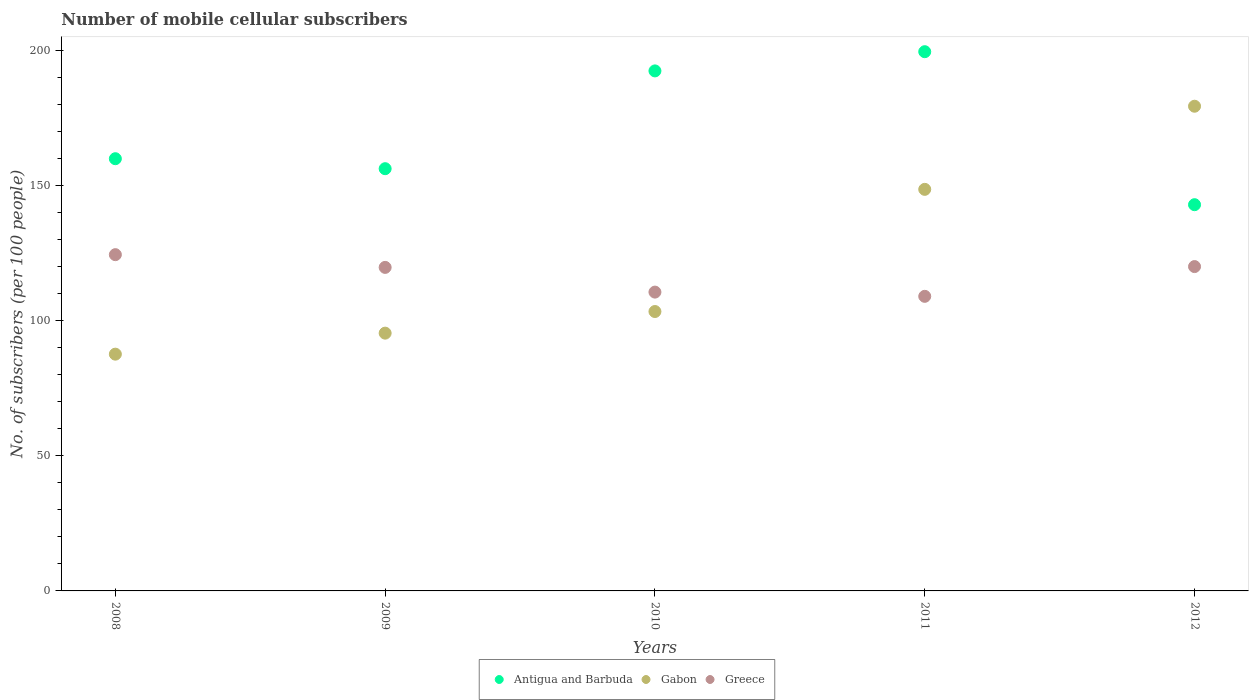What is the number of mobile cellular subscribers in Greece in 2011?
Your response must be concise. 109.08. Across all years, what is the maximum number of mobile cellular subscribers in Antigua and Barbuda?
Ensure brevity in your answer.  199.66. Across all years, what is the minimum number of mobile cellular subscribers in Antigua and Barbuda?
Keep it short and to the point. 143.01. In which year was the number of mobile cellular subscribers in Antigua and Barbuda maximum?
Your response must be concise. 2011. What is the total number of mobile cellular subscribers in Antigua and Barbuda in the graph?
Keep it short and to the point. 851.61. What is the difference between the number of mobile cellular subscribers in Gabon in 2009 and that in 2010?
Provide a succinct answer. -8.01. What is the difference between the number of mobile cellular subscribers in Greece in 2011 and the number of mobile cellular subscribers in Antigua and Barbuda in 2008?
Give a very brief answer. -50.96. What is the average number of mobile cellular subscribers in Greece per year?
Your answer should be compact. 116.82. In the year 2011, what is the difference between the number of mobile cellular subscribers in Gabon and number of mobile cellular subscribers in Antigua and Barbuda?
Offer a very short reply. -50.97. What is the ratio of the number of mobile cellular subscribers in Antigua and Barbuda in 2008 to that in 2009?
Keep it short and to the point. 1.02. Is the number of mobile cellular subscribers in Greece in 2010 less than that in 2012?
Provide a succinct answer. Yes. Is the difference between the number of mobile cellular subscribers in Gabon in 2008 and 2009 greater than the difference between the number of mobile cellular subscribers in Antigua and Barbuda in 2008 and 2009?
Offer a terse response. No. What is the difference between the highest and the second highest number of mobile cellular subscribers in Gabon?
Your answer should be compact. 30.78. What is the difference between the highest and the lowest number of mobile cellular subscribers in Gabon?
Provide a succinct answer. 91.8. Is the sum of the number of mobile cellular subscribers in Greece in 2008 and 2012 greater than the maximum number of mobile cellular subscribers in Antigua and Barbuda across all years?
Your answer should be compact. Yes. Is it the case that in every year, the sum of the number of mobile cellular subscribers in Greece and number of mobile cellular subscribers in Gabon  is greater than the number of mobile cellular subscribers in Antigua and Barbuda?
Your answer should be very brief. Yes. How many years are there in the graph?
Provide a short and direct response. 5. What is the difference between two consecutive major ticks on the Y-axis?
Your response must be concise. 50. How are the legend labels stacked?
Provide a succinct answer. Horizontal. What is the title of the graph?
Offer a terse response. Number of mobile cellular subscribers. Does "Madagascar" appear as one of the legend labels in the graph?
Ensure brevity in your answer.  No. What is the label or title of the Y-axis?
Keep it short and to the point. No. of subscribers (per 100 people). What is the No. of subscribers (per 100 people) of Antigua and Barbuda in 2008?
Offer a very short reply. 160.04. What is the No. of subscribers (per 100 people) in Gabon in 2008?
Keep it short and to the point. 87.67. What is the No. of subscribers (per 100 people) of Greece in 2008?
Offer a terse response. 124.51. What is the No. of subscribers (per 100 people) in Antigua and Barbuda in 2009?
Your response must be concise. 156.34. What is the No. of subscribers (per 100 people) of Gabon in 2009?
Provide a short and direct response. 95.45. What is the No. of subscribers (per 100 people) in Greece in 2009?
Make the answer very short. 119.8. What is the No. of subscribers (per 100 people) of Antigua and Barbuda in 2010?
Offer a very short reply. 192.55. What is the No. of subscribers (per 100 people) of Gabon in 2010?
Keep it short and to the point. 103.46. What is the No. of subscribers (per 100 people) of Greece in 2010?
Provide a short and direct response. 110.65. What is the No. of subscribers (per 100 people) of Antigua and Barbuda in 2011?
Provide a succinct answer. 199.66. What is the No. of subscribers (per 100 people) of Gabon in 2011?
Make the answer very short. 148.69. What is the No. of subscribers (per 100 people) of Greece in 2011?
Offer a terse response. 109.08. What is the No. of subscribers (per 100 people) of Antigua and Barbuda in 2012?
Your response must be concise. 143.01. What is the No. of subscribers (per 100 people) of Gabon in 2012?
Provide a succinct answer. 179.47. What is the No. of subscribers (per 100 people) in Greece in 2012?
Make the answer very short. 120.1. Across all years, what is the maximum No. of subscribers (per 100 people) in Antigua and Barbuda?
Offer a terse response. 199.66. Across all years, what is the maximum No. of subscribers (per 100 people) in Gabon?
Ensure brevity in your answer.  179.47. Across all years, what is the maximum No. of subscribers (per 100 people) in Greece?
Provide a short and direct response. 124.51. Across all years, what is the minimum No. of subscribers (per 100 people) in Antigua and Barbuda?
Keep it short and to the point. 143.01. Across all years, what is the minimum No. of subscribers (per 100 people) in Gabon?
Ensure brevity in your answer.  87.67. Across all years, what is the minimum No. of subscribers (per 100 people) in Greece?
Your answer should be compact. 109.08. What is the total No. of subscribers (per 100 people) in Antigua and Barbuda in the graph?
Provide a short and direct response. 851.61. What is the total No. of subscribers (per 100 people) in Gabon in the graph?
Provide a succinct answer. 614.74. What is the total No. of subscribers (per 100 people) of Greece in the graph?
Your answer should be very brief. 584.12. What is the difference between the No. of subscribers (per 100 people) in Antigua and Barbuda in 2008 and that in 2009?
Your answer should be very brief. 3.7. What is the difference between the No. of subscribers (per 100 people) of Gabon in 2008 and that in 2009?
Ensure brevity in your answer.  -7.78. What is the difference between the No. of subscribers (per 100 people) in Greece in 2008 and that in 2009?
Offer a terse response. 4.71. What is the difference between the No. of subscribers (per 100 people) in Antigua and Barbuda in 2008 and that in 2010?
Your answer should be compact. -32.51. What is the difference between the No. of subscribers (per 100 people) of Gabon in 2008 and that in 2010?
Your answer should be very brief. -15.79. What is the difference between the No. of subscribers (per 100 people) in Greece in 2008 and that in 2010?
Ensure brevity in your answer.  13.86. What is the difference between the No. of subscribers (per 100 people) of Antigua and Barbuda in 2008 and that in 2011?
Ensure brevity in your answer.  -39.62. What is the difference between the No. of subscribers (per 100 people) in Gabon in 2008 and that in 2011?
Your answer should be very brief. -61.02. What is the difference between the No. of subscribers (per 100 people) of Greece in 2008 and that in 2011?
Provide a short and direct response. 15.43. What is the difference between the No. of subscribers (per 100 people) in Antigua and Barbuda in 2008 and that in 2012?
Your response must be concise. 17.03. What is the difference between the No. of subscribers (per 100 people) of Gabon in 2008 and that in 2012?
Keep it short and to the point. -91.8. What is the difference between the No. of subscribers (per 100 people) of Greece in 2008 and that in 2012?
Give a very brief answer. 4.41. What is the difference between the No. of subscribers (per 100 people) of Antigua and Barbuda in 2009 and that in 2010?
Keep it short and to the point. -36.21. What is the difference between the No. of subscribers (per 100 people) in Gabon in 2009 and that in 2010?
Make the answer very short. -8.01. What is the difference between the No. of subscribers (per 100 people) of Greece in 2009 and that in 2010?
Make the answer very short. 9.15. What is the difference between the No. of subscribers (per 100 people) in Antigua and Barbuda in 2009 and that in 2011?
Your response must be concise. -43.32. What is the difference between the No. of subscribers (per 100 people) in Gabon in 2009 and that in 2011?
Your answer should be very brief. -53.25. What is the difference between the No. of subscribers (per 100 people) in Greece in 2009 and that in 2011?
Provide a succinct answer. 10.72. What is the difference between the No. of subscribers (per 100 people) in Antigua and Barbuda in 2009 and that in 2012?
Provide a succinct answer. 13.33. What is the difference between the No. of subscribers (per 100 people) of Gabon in 2009 and that in 2012?
Offer a very short reply. -84.02. What is the difference between the No. of subscribers (per 100 people) of Greece in 2009 and that in 2012?
Keep it short and to the point. -0.3. What is the difference between the No. of subscribers (per 100 people) in Antigua and Barbuda in 2010 and that in 2011?
Provide a succinct answer. -7.11. What is the difference between the No. of subscribers (per 100 people) in Gabon in 2010 and that in 2011?
Make the answer very short. -45.24. What is the difference between the No. of subscribers (per 100 people) in Greece in 2010 and that in 2011?
Provide a succinct answer. 1.57. What is the difference between the No. of subscribers (per 100 people) of Antigua and Barbuda in 2010 and that in 2012?
Provide a short and direct response. 49.54. What is the difference between the No. of subscribers (per 100 people) of Gabon in 2010 and that in 2012?
Provide a short and direct response. -76.02. What is the difference between the No. of subscribers (per 100 people) of Greece in 2010 and that in 2012?
Your answer should be very brief. -9.45. What is the difference between the No. of subscribers (per 100 people) of Antigua and Barbuda in 2011 and that in 2012?
Keep it short and to the point. 56.65. What is the difference between the No. of subscribers (per 100 people) of Gabon in 2011 and that in 2012?
Provide a short and direct response. -30.78. What is the difference between the No. of subscribers (per 100 people) in Greece in 2011 and that in 2012?
Ensure brevity in your answer.  -11.02. What is the difference between the No. of subscribers (per 100 people) of Antigua and Barbuda in 2008 and the No. of subscribers (per 100 people) of Gabon in 2009?
Keep it short and to the point. 64.59. What is the difference between the No. of subscribers (per 100 people) in Antigua and Barbuda in 2008 and the No. of subscribers (per 100 people) in Greece in 2009?
Offer a terse response. 40.24. What is the difference between the No. of subscribers (per 100 people) in Gabon in 2008 and the No. of subscribers (per 100 people) in Greece in 2009?
Make the answer very short. -32.13. What is the difference between the No. of subscribers (per 100 people) in Antigua and Barbuda in 2008 and the No. of subscribers (per 100 people) in Gabon in 2010?
Provide a succinct answer. 56.58. What is the difference between the No. of subscribers (per 100 people) in Antigua and Barbuda in 2008 and the No. of subscribers (per 100 people) in Greece in 2010?
Make the answer very short. 49.39. What is the difference between the No. of subscribers (per 100 people) in Gabon in 2008 and the No. of subscribers (per 100 people) in Greece in 2010?
Your answer should be very brief. -22.98. What is the difference between the No. of subscribers (per 100 people) of Antigua and Barbuda in 2008 and the No. of subscribers (per 100 people) of Gabon in 2011?
Your response must be concise. 11.35. What is the difference between the No. of subscribers (per 100 people) of Antigua and Barbuda in 2008 and the No. of subscribers (per 100 people) of Greece in 2011?
Your answer should be compact. 50.96. What is the difference between the No. of subscribers (per 100 people) of Gabon in 2008 and the No. of subscribers (per 100 people) of Greece in 2011?
Ensure brevity in your answer.  -21.41. What is the difference between the No. of subscribers (per 100 people) in Antigua and Barbuda in 2008 and the No. of subscribers (per 100 people) in Gabon in 2012?
Your response must be concise. -19.43. What is the difference between the No. of subscribers (per 100 people) of Antigua and Barbuda in 2008 and the No. of subscribers (per 100 people) of Greece in 2012?
Keep it short and to the point. 39.94. What is the difference between the No. of subscribers (per 100 people) of Gabon in 2008 and the No. of subscribers (per 100 people) of Greece in 2012?
Give a very brief answer. -32.43. What is the difference between the No. of subscribers (per 100 people) in Antigua and Barbuda in 2009 and the No. of subscribers (per 100 people) in Gabon in 2010?
Your response must be concise. 52.89. What is the difference between the No. of subscribers (per 100 people) of Antigua and Barbuda in 2009 and the No. of subscribers (per 100 people) of Greece in 2010?
Offer a terse response. 45.7. What is the difference between the No. of subscribers (per 100 people) of Gabon in 2009 and the No. of subscribers (per 100 people) of Greece in 2010?
Offer a terse response. -15.2. What is the difference between the No. of subscribers (per 100 people) in Antigua and Barbuda in 2009 and the No. of subscribers (per 100 people) in Gabon in 2011?
Your response must be concise. 7.65. What is the difference between the No. of subscribers (per 100 people) of Antigua and Barbuda in 2009 and the No. of subscribers (per 100 people) of Greece in 2011?
Provide a short and direct response. 47.27. What is the difference between the No. of subscribers (per 100 people) of Gabon in 2009 and the No. of subscribers (per 100 people) of Greece in 2011?
Ensure brevity in your answer.  -13.63. What is the difference between the No. of subscribers (per 100 people) in Antigua and Barbuda in 2009 and the No. of subscribers (per 100 people) in Gabon in 2012?
Offer a very short reply. -23.13. What is the difference between the No. of subscribers (per 100 people) in Antigua and Barbuda in 2009 and the No. of subscribers (per 100 people) in Greece in 2012?
Your response must be concise. 36.25. What is the difference between the No. of subscribers (per 100 people) in Gabon in 2009 and the No. of subscribers (per 100 people) in Greece in 2012?
Give a very brief answer. -24.65. What is the difference between the No. of subscribers (per 100 people) of Antigua and Barbuda in 2010 and the No. of subscribers (per 100 people) of Gabon in 2011?
Offer a terse response. 43.86. What is the difference between the No. of subscribers (per 100 people) in Antigua and Barbuda in 2010 and the No. of subscribers (per 100 people) in Greece in 2011?
Keep it short and to the point. 83.47. What is the difference between the No. of subscribers (per 100 people) of Gabon in 2010 and the No. of subscribers (per 100 people) of Greece in 2011?
Give a very brief answer. -5.62. What is the difference between the No. of subscribers (per 100 people) in Antigua and Barbuda in 2010 and the No. of subscribers (per 100 people) in Gabon in 2012?
Provide a succinct answer. 13.08. What is the difference between the No. of subscribers (per 100 people) of Antigua and Barbuda in 2010 and the No. of subscribers (per 100 people) of Greece in 2012?
Give a very brief answer. 72.46. What is the difference between the No. of subscribers (per 100 people) in Gabon in 2010 and the No. of subscribers (per 100 people) in Greece in 2012?
Make the answer very short. -16.64. What is the difference between the No. of subscribers (per 100 people) in Antigua and Barbuda in 2011 and the No. of subscribers (per 100 people) in Gabon in 2012?
Offer a terse response. 20.19. What is the difference between the No. of subscribers (per 100 people) of Antigua and Barbuda in 2011 and the No. of subscribers (per 100 people) of Greece in 2012?
Your answer should be very brief. 79.57. What is the difference between the No. of subscribers (per 100 people) of Gabon in 2011 and the No. of subscribers (per 100 people) of Greece in 2012?
Offer a very short reply. 28.6. What is the average No. of subscribers (per 100 people) in Antigua and Barbuda per year?
Give a very brief answer. 170.32. What is the average No. of subscribers (per 100 people) of Gabon per year?
Provide a succinct answer. 122.95. What is the average No. of subscribers (per 100 people) in Greece per year?
Make the answer very short. 116.82. In the year 2008, what is the difference between the No. of subscribers (per 100 people) of Antigua and Barbuda and No. of subscribers (per 100 people) of Gabon?
Offer a very short reply. 72.37. In the year 2008, what is the difference between the No. of subscribers (per 100 people) of Antigua and Barbuda and No. of subscribers (per 100 people) of Greece?
Provide a short and direct response. 35.53. In the year 2008, what is the difference between the No. of subscribers (per 100 people) in Gabon and No. of subscribers (per 100 people) in Greece?
Your response must be concise. -36.84. In the year 2009, what is the difference between the No. of subscribers (per 100 people) in Antigua and Barbuda and No. of subscribers (per 100 people) in Gabon?
Offer a terse response. 60.9. In the year 2009, what is the difference between the No. of subscribers (per 100 people) of Antigua and Barbuda and No. of subscribers (per 100 people) of Greece?
Ensure brevity in your answer.  36.55. In the year 2009, what is the difference between the No. of subscribers (per 100 people) of Gabon and No. of subscribers (per 100 people) of Greece?
Make the answer very short. -24.35. In the year 2010, what is the difference between the No. of subscribers (per 100 people) in Antigua and Barbuda and No. of subscribers (per 100 people) in Gabon?
Your response must be concise. 89.1. In the year 2010, what is the difference between the No. of subscribers (per 100 people) of Antigua and Barbuda and No. of subscribers (per 100 people) of Greece?
Give a very brief answer. 81.91. In the year 2010, what is the difference between the No. of subscribers (per 100 people) in Gabon and No. of subscribers (per 100 people) in Greece?
Give a very brief answer. -7.19. In the year 2011, what is the difference between the No. of subscribers (per 100 people) in Antigua and Barbuda and No. of subscribers (per 100 people) in Gabon?
Keep it short and to the point. 50.97. In the year 2011, what is the difference between the No. of subscribers (per 100 people) of Antigua and Barbuda and No. of subscribers (per 100 people) of Greece?
Give a very brief answer. 90.59. In the year 2011, what is the difference between the No. of subscribers (per 100 people) of Gabon and No. of subscribers (per 100 people) of Greece?
Your response must be concise. 39.61. In the year 2012, what is the difference between the No. of subscribers (per 100 people) in Antigua and Barbuda and No. of subscribers (per 100 people) in Gabon?
Provide a succinct answer. -36.46. In the year 2012, what is the difference between the No. of subscribers (per 100 people) in Antigua and Barbuda and No. of subscribers (per 100 people) in Greece?
Give a very brief answer. 22.92. In the year 2012, what is the difference between the No. of subscribers (per 100 people) in Gabon and No. of subscribers (per 100 people) in Greece?
Your answer should be compact. 59.38. What is the ratio of the No. of subscribers (per 100 people) in Antigua and Barbuda in 2008 to that in 2009?
Keep it short and to the point. 1.02. What is the ratio of the No. of subscribers (per 100 people) in Gabon in 2008 to that in 2009?
Provide a succinct answer. 0.92. What is the ratio of the No. of subscribers (per 100 people) of Greece in 2008 to that in 2009?
Keep it short and to the point. 1.04. What is the ratio of the No. of subscribers (per 100 people) of Antigua and Barbuda in 2008 to that in 2010?
Your answer should be compact. 0.83. What is the ratio of the No. of subscribers (per 100 people) in Gabon in 2008 to that in 2010?
Ensure brevity in your answer.  0.85. What is the ratio of the No. of subscribers (per 100 people) in Greece in 2008 to that in 2010?
Offer a very short reply. 1.13. What is the ratio of the No. of subscribers (per 100 people) of Antigua and Barbuda in 2008 to that in 2011?
Offer a very short reply. 0.8. What is the ratio of the No. of subscribers (per 100 people) of Gabon in 2008 to that in 2011?
Offer a very short reply. 0.59. What is the ratio of the No. of subscribers (per 100 people) in Greece in 2008 to that in 2011?
Provide a succinct answer. 1.14. What is the ratio of the No. of subscribers (per 100 people) in Antigua and Barbuda in 2008 to that in 2012?
Your answer should be compact. 1.12. What is the ratio of the No. of subscribers (per 100 people) in Gabon in 2008 to that in 2012?
Offer a very short reply. 0.49. What is the ratio of the No. of subscribers (per 100 people) in Greece in 2008 to that in 2012?
Provide a succinct answer. 1.04. What is the ratio of the No. of subscribers (per 100 people) of Antigua and Barbuda in 2009 to that in 2010?
Make the answer very short. 0.81. What is the ratio of the No. of subscribers (per 100 people) of Gabon in 2009 to that in 2010?
Provide a succinct answer. 0.92. What is the ratio of the No. of subscribers (per 100 people) of Greece in 2009 to that in 2010?
Ensure brevity in your answer.  1.08. What is the ratio of the No. of subscribers (per 100 people) in Antigua and Barbuda in 2009 to that in 2011?
Your response must be concise. 0.78. What is the ratio of the No. of subscribers (per 100 people) of Gabon in 2009 to that in 2011?
Ensure brevity in your answer.  0.64. What is the ratio of the No. of subscribers (per 100 people) in Greece in 2009 to that in 2011?
Keep it short and to the point. 1.1. What is the ratio of the No. of subscribers (per 100 people) of Antigua and Barbuda in 2009 to that in 2012?
Provide a succinct answer. 1.09. What is the ratio of the No. of subscribers (per 100 people) of Gabon in 2009 to that in 2012?
Offer a very short reply. 0.53. What is the ratio of the No. of subscribers (per 100 people) in Greece in 2009 to that in 2012?
Offer a terse response. 1. What is the ratio of the No. of subscribers (per 100 people) of Antigua and Barbuda in 2010 to that in 2011?
Make the answer very short. 0.96. What is the ratio of the No. of subscribers (per 100 people) of Gabon in 2010 to that in 2011?
Offer a very short reply. 0.7. What is the ratio of the No. of subscribers (per 100 people) in Greece in 2010 to that in 2011?
Your answer should be very brief. 1.01. What is the ratio of the No. of subscribers (per 100 people) in Antigua and Barbuda in 2010 to that in 2012?
Offer a terse response. 1.35. What is the ratio of the No. of subscribers (per 100 people) in Gabon in 2010 to that in 2012?
Your answer should be compact. 0.58. What is the ratio of the No. of subscribers (per 100 people) of Greece in 2010 to that in 2012?
Give a very brief answer. 0.92. What is the ratio of the No. of subscribers (per 100 people) of Antigua and Barbuda in 2011 to that in 2012?
Provide a succinct answer. 1.4. What is the ratio of the No. of subscribers (per 100 people) of Gabon in 2011 to that in 2012?
Offer a terse response. 0.83. What is the ratio of the No. of subscribers (per 100 people) in Greece in 2011 to that in 2012?
Keep it short and to the point. 0.91. What is the difference between the highest and the second highest No. of subscribers (per 100 people) of Antigua and Barbuda?
Your answer should be compact. 7.11. What is the difference between the highest and the second highest No. of subscribers (per 100 people) of Gabon?
Provide a succinct answer. 30.78. What is the difference between the highest and the second highest No. of subscribers (per 100 people) in Greece?
Keep it short and to the point. 4.41. What is the difference between the highest and the lowest No. of subscribers (per 100 people) in Antigua and Barbuda?
Ensure brevity in your answer.  56.65. What is the difference between the highest and the lowest No. of subscribers (per 100 people) of Gabon?
Ensure brevity in your answer.  91.8. What is the difference between the highest and the lowest No. of subscribers (per 100 people) in Greece?
Ensure brevity in your answer.  15.43. 